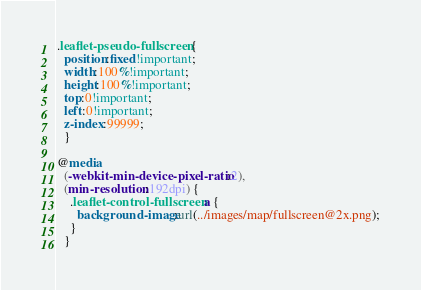Convert code to text. <code><loc_0><loc_0><loc_500><loc_500><_CSS_>
.leaflet-pseudo-fullscreen {
  position:fixed!important;
  width:100%!important;
  height:100%!important;
  top:0!important;
  left:0!important;
  z-index:99999;
  }

@media
  (-webkit-min-device-pixel-ratio:2),
  (min-resolution:192dpi) {
    .leaflet-control-fullscreen a {
      background-image:url(../images/map/fullscreen@2x.png);
    }
  }
</code> 